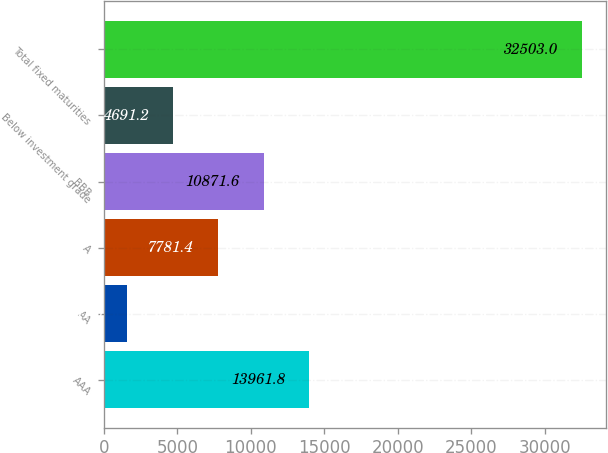Convert chart. <chart><loc_0><loc_0><loc_500><loc_500><bar_chart><fcel>AAA<fcel>AA<fcel>A<fcel>BBB<fcel>Below investment grade<fcel>Total fixed maturities<nl><fcel>13961.8<fcel>1601<fcel>7781.4<fcel>10871.6<fcel>4691.2<fcel>32503<nl></chart> 